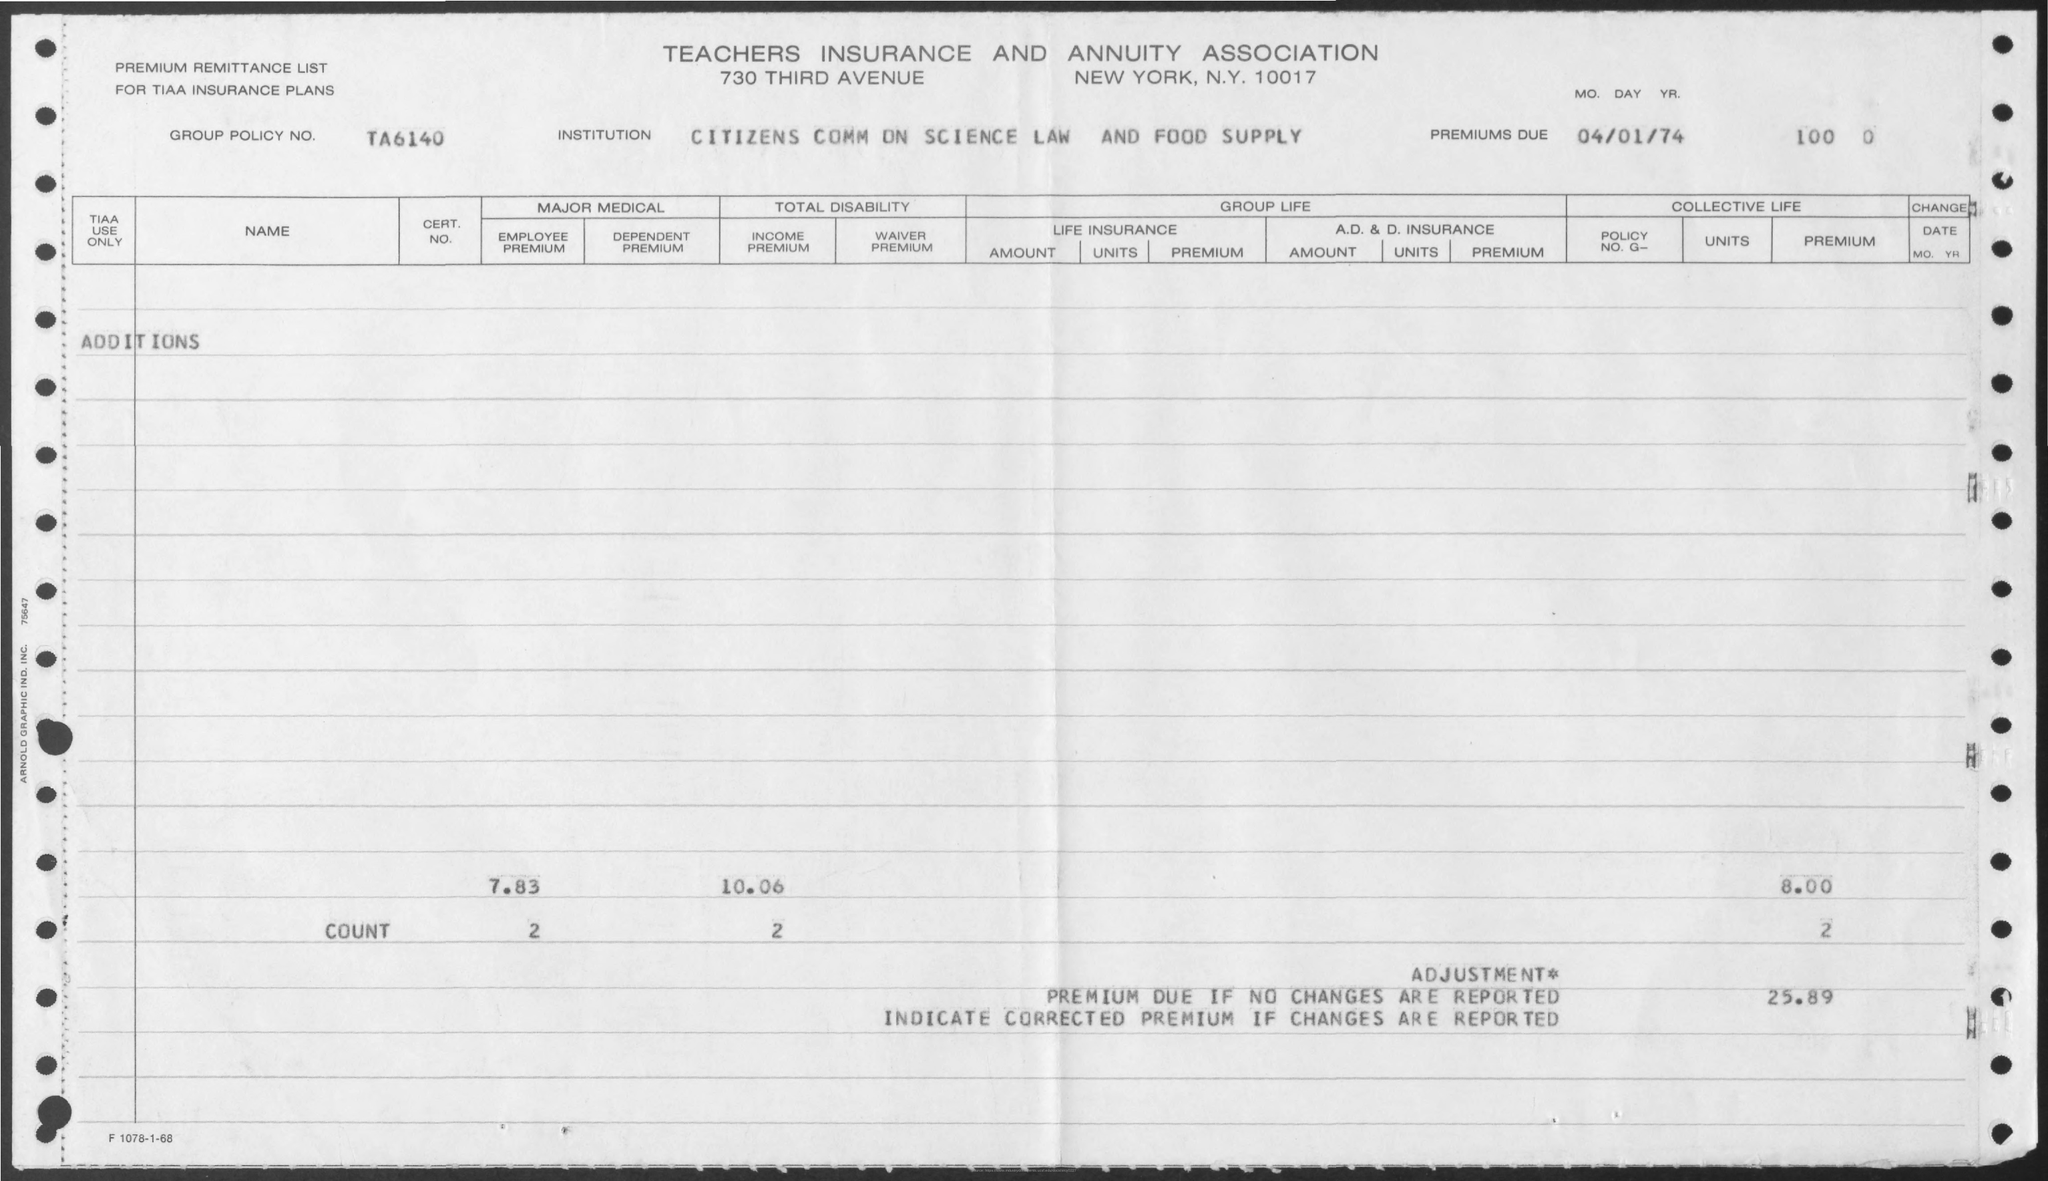Indicate a few pertinent items in this graphic. The name of the institution is the Citizens Commission on Science, Law, and Food Supply. The title of the document is 'Teachers Insurance and Annuity Association.' What is the Group Policy Number?" is a question that seeks information about a specific policy or set of policies that are associated with a particular group or organization. In this case, the policy number is "TA6140..". 